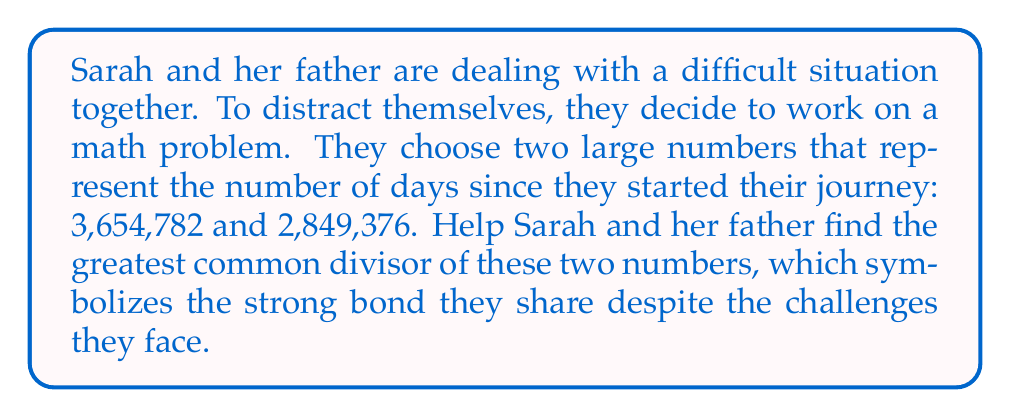Solve this math problem. To find the greatest common divisor (GCD) of 3,654,782 and 2,849,376, we'll use the Euclidean algorithm. This method is based on the principle that the GCD of two numbers is also the GCD of the smaller number and the remainder of the larger number divided by the smaller one.

Let's denote $a = 3,654,782$ and $b = 2,849,376$.

Step 1: Divide $a$ by $b$
$$3,654,782 = 1 \times 2,849,376 + 805,406$$
$$GCD(a,b) = GCD(2,849,376, 805,406)$$

Step 2: Divide 2,849,376 by 805,406
$$2,849,376 = 3 \times 805,406 + 433,158$$
$$GCD(2,849,376, 805,406) = GCD(805,406, 433,158)$$

Step 3: Divide 805,406 by 433,158
$$805,406 = 1 \times 433,158 + 372,248$$
$$GCD(805,406, 433,158) = GCD(433,158, 372,248)$$

Step 4: Divide 433,158 by 372,248
$$433,158 = 1 \times 372,248 + 60,910$$
$$GCD(433,158, 372,248) = GCD(372,248, 60,910)$$

Step 5: Divide 372,248 by 60,910
$$372,248 = 6 \times 60,910 + 6,788$$
$$GCD(372,248, 60,910) = GCD(60,910, 6,788)$$

Step 6: Divide 60,910 by 6,788
$$60,910 = 8 \times 6,788 + 6,606$$
$$GCD(60,910, 6,788) = GCD(6,788, 6,606)$$

Step 7: Divide 6,788 by 6,606
$$6,788 = 1 \times 6,606 + 182$$
$$GCD(6,788, 6,606) = GCD(6,606, 182)$$

Step 8: Divide 6,606 by 182
$$6,606 = 36 \times 182 + 52$$
$$GCD(6,606, 182) = GCD(182, 52)$$

Step 9: Divide 182 by 52
$$182 = 3 \times 52 + 26$$
$$GCD(182, 52) = GCD(52, 26)$$

Step 10: Divide 52 by 26
$$52 = 2 \times 26 + 0$$

The process stops when we get a remainder of 0. The last non-zero remainder is the GCD.
Answer: The greatest common divisor of 3,654,782 and 2,849,376 is 26. 